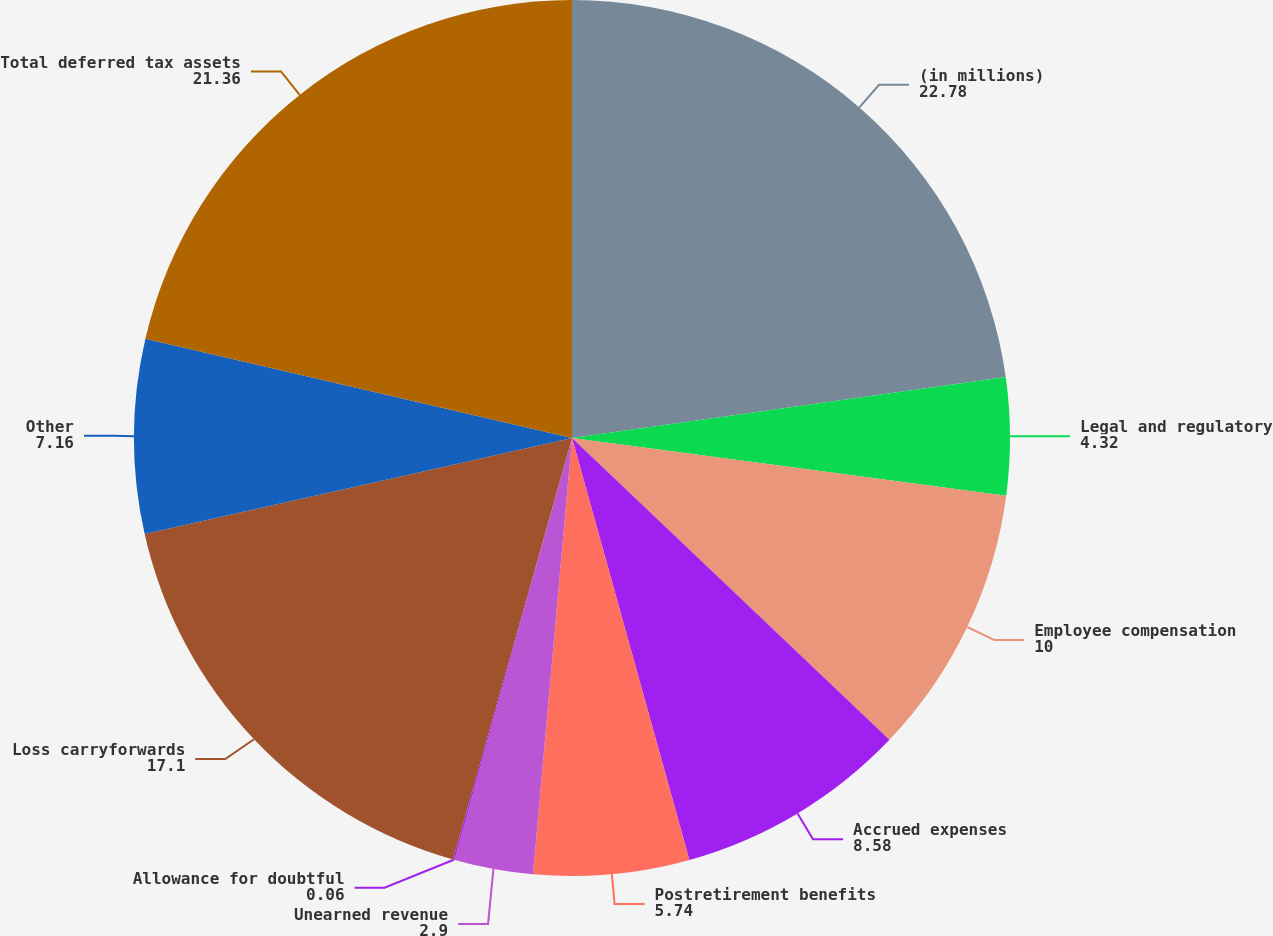Convert chart. <chart><loc_0><loc_0><loc_500><loc_500><pie_chart><fcel>(in millions)<fcel>Legal and regulatory<fcel>Employee compensation<fcel>Accrued expenses<fcel>Postretirement benefits<fcel>Unearned revenue<fcel>Allowance for doubtful<fcel>Loss carryforwards<fcel>Other<fcel>Total deferred tax assets<nl><fcel>22.78%<fcel>4.32%<fcel>10.0%<fcel>8.58%<fcel>5.74%<fcel>2.9%<fcel>0.06%<fcel>17.1%<fcel>7.16%<fcel>21.36%<nl></chart> 